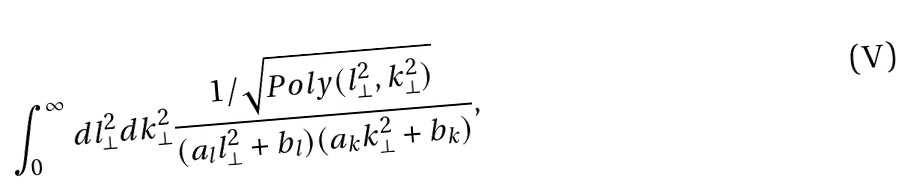<formula> <loc_0><loc_0><loc_500><loc_500>\int _ { 0 } ^ { \infty } d l _ { \bot } ^ { 2 } d k _ { \bot } ^ { 2 } \frac { 1 / \sqrt { P o l y ( l _ { \bot } ^ { 2 } , k _ { \bot } ^ { 2 } ) } } { ( a _ { l } l _ { \bot } ^ { 2 } + b _ { l } ) ( a _ { k } k _ { \bot } ^ { 2 } + b _ { k } ) } ,</formula> 